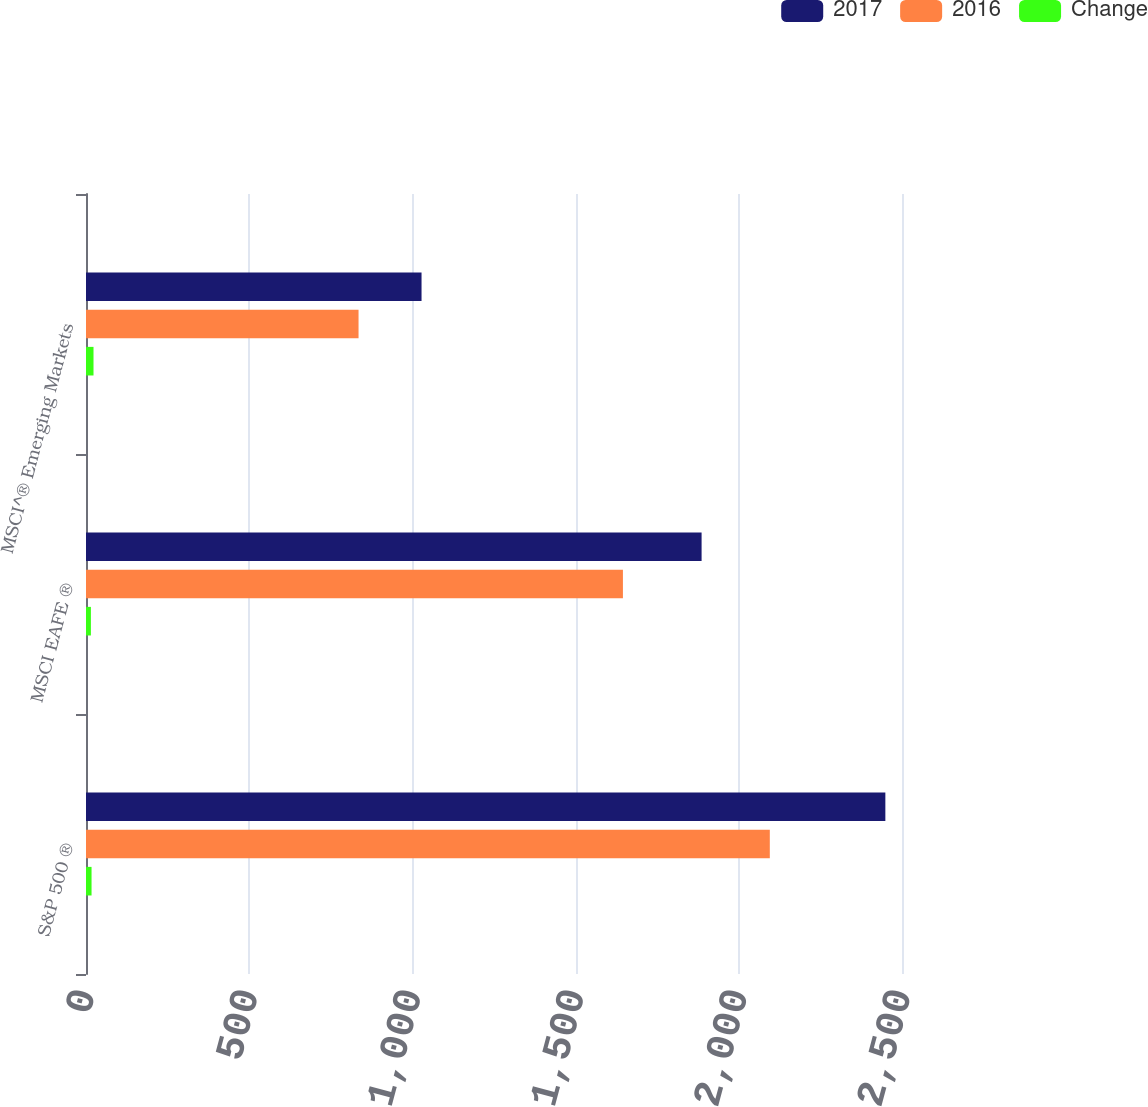Convert chart to OTSL. <chart><loc_0><loc_0><loc_500><loc_500><stacked_bar_chart><ecel><fcel>S&P 500 ®<fcel>MSCI EAFE ®<fcel>MSCI^® Emerging Markets<nl><fcel>2017<fcel>2449<fcel>1886<fcel>1028<nl><fcel>2016<fcel>2095<fcel>1645<fcel>835<nl><fcel>Change<fcel>17<fcel>15<fcel>23<nl></chart> 